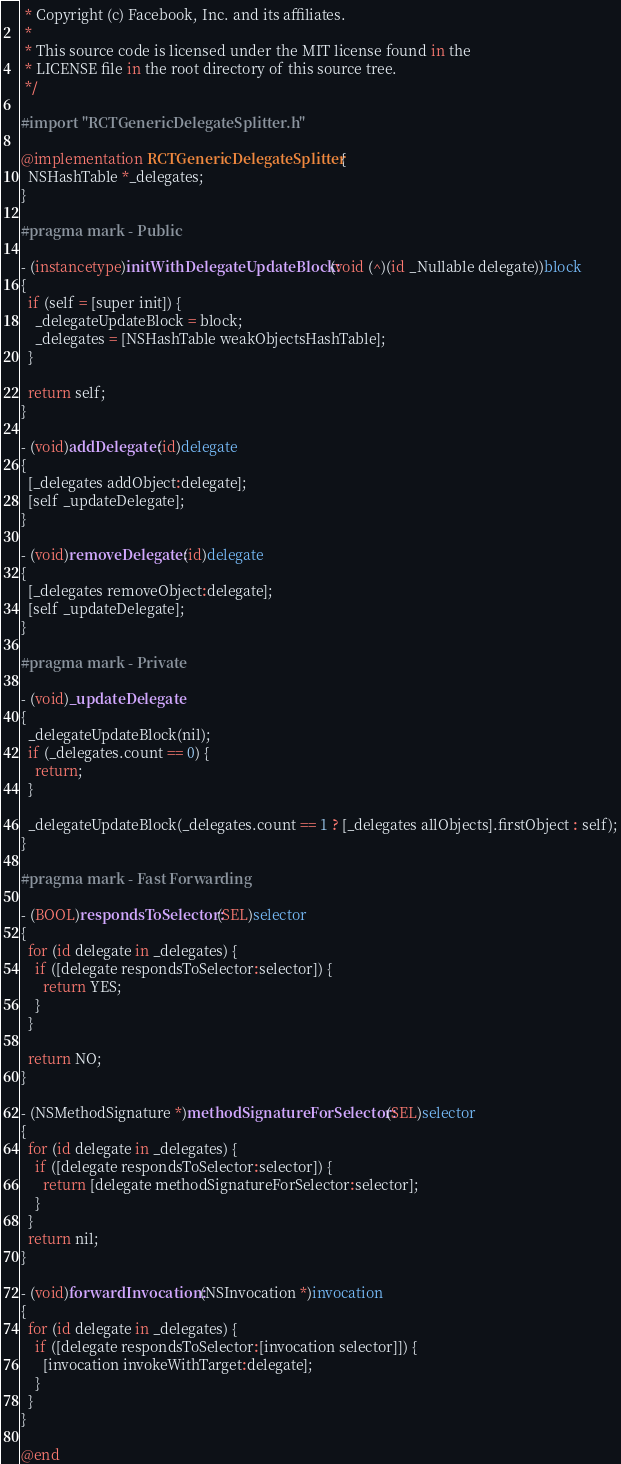Convert code to text. <code><loc_0><loc_0><loc_500><loc_500><_ObjectiveC_> * Copyright (c) Facebook, Inc. and its affiliates.
 *
 * This source code is licensed under the MIT license found in the
 * LICENSE file in the root directory of this source tree.
 */

#import "RCTGenericDelegateSplitter.h"

@implementation RCTGenericDelegateSplitter {
  NSHashTable *_delegates;
}

#pragma mark - Public

- (instancetype)initWithDelegateUpdateBlock:(void (^)(id _Nullable delegate))block
{
  if (self = [super init]) {
    _delegateUpdateBlock = block;
    _delegates = [NSHashTable weakObjectsHashTable];
  }

  return self;
}

- (void)addDelegate:(id)delegate
{
  [_delegates addObject:delegate];
  [self _updateDelegate];
}

- (void)removeDelegate:(id)delegate
{
  [_delegates removeObject:delegate];
  [self _updateDelegate];
}

#pragma mark - Private

- (void)_updateDelegate
{
  _delegateUpdateBlock(nil);
  if (_delegates.count == 0) {
    return;
  }

  _delegateUpdateBlock(_delegates.count == 1 ? [_delegates allObjects].firstObject : self);
}

#pragma mark - Fast Forwarding

- (BOOL)respondsToSelector:(SEL)selector
{
  for (id delegate in _delegates) {
    if ([delegate respondsToSelector:selector]) {
      return YES;
    }
  }

  return NO;
}

- (NSMethodSignature *)methodSignatureForSelector:(SEL)selector
{
  for (id delegate in _delegates) {
    if ([delegate respondsToSelector:selector]) {
      return [delegate methodSignatureForSelector:selector];
    }
  }
  return nil;
}

- (void)forwardInvocation:(NSInvocation *)invocation
{
  for (id delegate in _delegates) {
    if ([delegate respondsToSelector:[invocation selector]]) {
      [invocation invokeWithTarget:delegate];
    }
  }
}

@end
</code> 